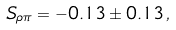Convert formula to latex. <formula><loc_0><loc_0><loc_500><loc_500>S _ { \rho \pi } = - 0 . 1 3 \pm 0 . 1 3 \, ,</formula> 